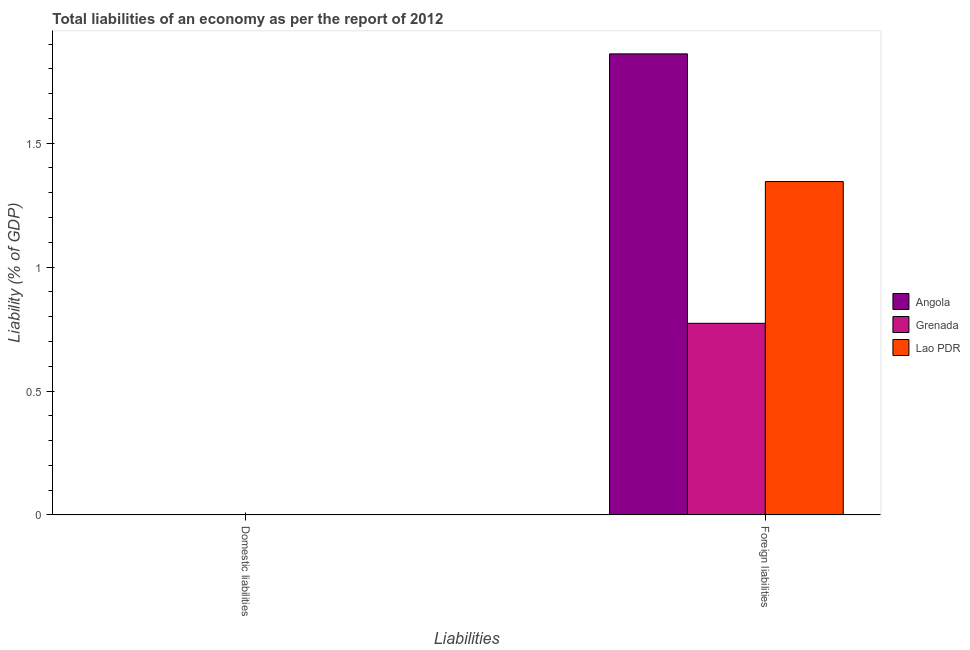How many bars are there on the 1st tick from the left?
Offer a very short reply. 0. How many bars are there on the 1st tick from the right?
Offer a very short reply. 3. What is the label of the 2nd group of bars from the left?
Offer a terse response. Foreign liabilities. Across all countries, what is the maximum incurrence of foreign liabilities?
Offer a very short reply. 1.86. Across all countries, what is the minimum incurrence of domestic liabilities?
Offer a very short reply. 0. In which country was the incurrence of foreign liabilities maximum?
Your answer should be compact. Angola. What is the total incurrence of domestic liabilities in the graph?
Provide a succinct answer. 0. What is the difference between the incurrence of foreign liabilities in Grenada and that in Angola?
Make the answer very short. -1.09. What is the difference between the incurrence of foreign liabilities in Grenada and the incurrence of domestic liabilities in Lao PDR?
Offer a terse response. 0.77. In how many countries, is the incurrence of foreign liabilities greater than 0.4 %?
Your answer should be compact. 3. What is the ratio of the incurrence of foreign liabilities in Angola to that in Lao PDR?
Offer a terse response. 1.38. Are all the bars in the graph horizontal?
Provide a short and direct response. No. How many countries are there in the graph?
Your answer should be very brief. 3. What is the difference between two consecutive major ticks on the Y-axis?
Keep it short and to the point. 0.5. Are the values on the major ticks of Y-axis written in scientific E-notation?
Make the answer very short. No. Does the graph contain any zero values?
Your answer should be very brief. Yes. Where does the legend appear in the graph?
Your answer should be very brief. Center right. What is the title of the graph?
Your response must be concise. Total liabilities of an economy as per the report of 2012. What is the label or title of the X-axis?
Offer a very short reply. Liabilities. What is the label or title of the Y-axis?
Your answer should be very brief. Liability (% of GDP). What is the Liability (% of GDP) in Angola in Domestic liabilities?
Give a very brief answer. 0. What is the Liability (% of GDP) of Grenada in Domestic liabilities?
Offer a terse response. 0. What is the Liability (% of GDP) of Lao PDR in Domestic liabilities?
Offer a terse response. 0. What is the Liability (% of GDP) in Angola in Foreign liabilities?
Give a very brief answer. 1.86. What is the Liability (% of GDP) in Grenada in Foreign liabilities?
Provide a short and direct response. 0.77. What is the Liability (% of GDP) of Lao PDR in Foreign liabilities?
Give a very brief answer. 1.35. Across all Liabilities, what is the maximum Liability (% of GDP) in Angola?
Offer a terse response. 1.86. Across all Liabilities, what is the maximum Liability (% of GDP) in Grenada?
Your answer should be compact. 0.77. Across all Liabilities, what is the maximum Liability (% of GDP) of Lao PDR?
Ensure brevity in your answer.  1.35. Across all Liabilities, what is the minimum Liability (% of GDP) in Angola?
Provide a short and direct response. 0. Across all Liabilities, what is the minimum Liability (% of GDP) of Lao PDR?
Make the answer very short. 0. What is the total Liability (% of GDP) in Angola in the graph?
Provide a succinct answer. 1.86. What is the total Liability (% of GDP) in Grenada in the graph?
Give a very brief answer. 0.77. What is the total Liability (% of GDP) of Lao PDR in the graph?
Ensure brevity in your answer.  1.35. What is the average Liability (% of GDP) of Angola per Liabilities?
Provide a short and direct response. 0.93. What is the average Liability (% of GDP) in Grenada per Liabilities?
Your answer should be compact. 0.39. What is the average Liability (% of GDP) of Lao PDR per Liabilities?
Give a very brief answer. 0.67. What is the difference between the Liability (% of GDP) in Angola and Liability (% of GDP) in Grenada in Foreign liabilities?
Keep it short and to the point. 1.09. What is the difference between the Liability (% of GDP) of Angola and Liability (% of GDP) of Lao PDR in Foreign liabilities?
Offer a very short reply. 0.52. What is the difference between the Liability (% of GDP) of Grenada and Liability (% of GDP) of Lao PDR in Foreign liabilities?
Provide a short and direct response. -0.57. What is the difference between the highest and the lowest Liability (% of GDP) in Angola?
Provide a short and direct response. 1.86. What is the difference between the highest and the lowest Liability (% of GDP) in Grenada?
Keep it short and to the point. 0.77. What is the difference between the highest and the lowest Liability (% of GDP) of Lao PDR?
Ensure brevity in your answer.  1.35. 